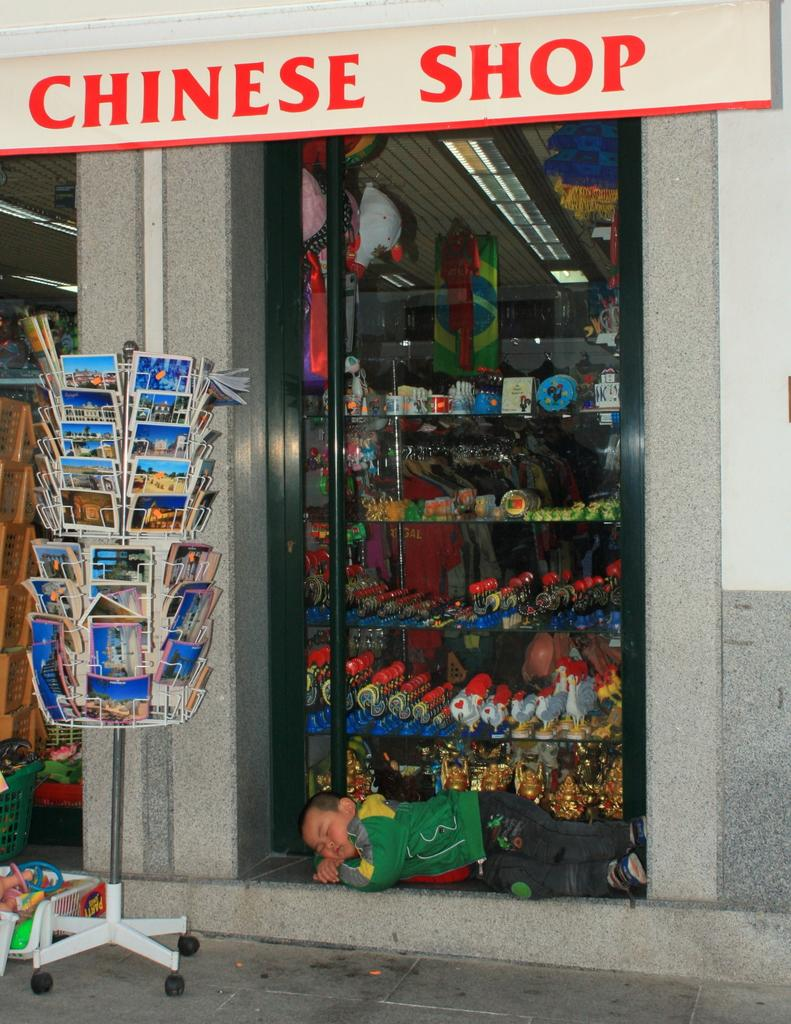<image>
Share a concise interpretation of the image provided. a CHINESE SHOP store front with post cards out in front 